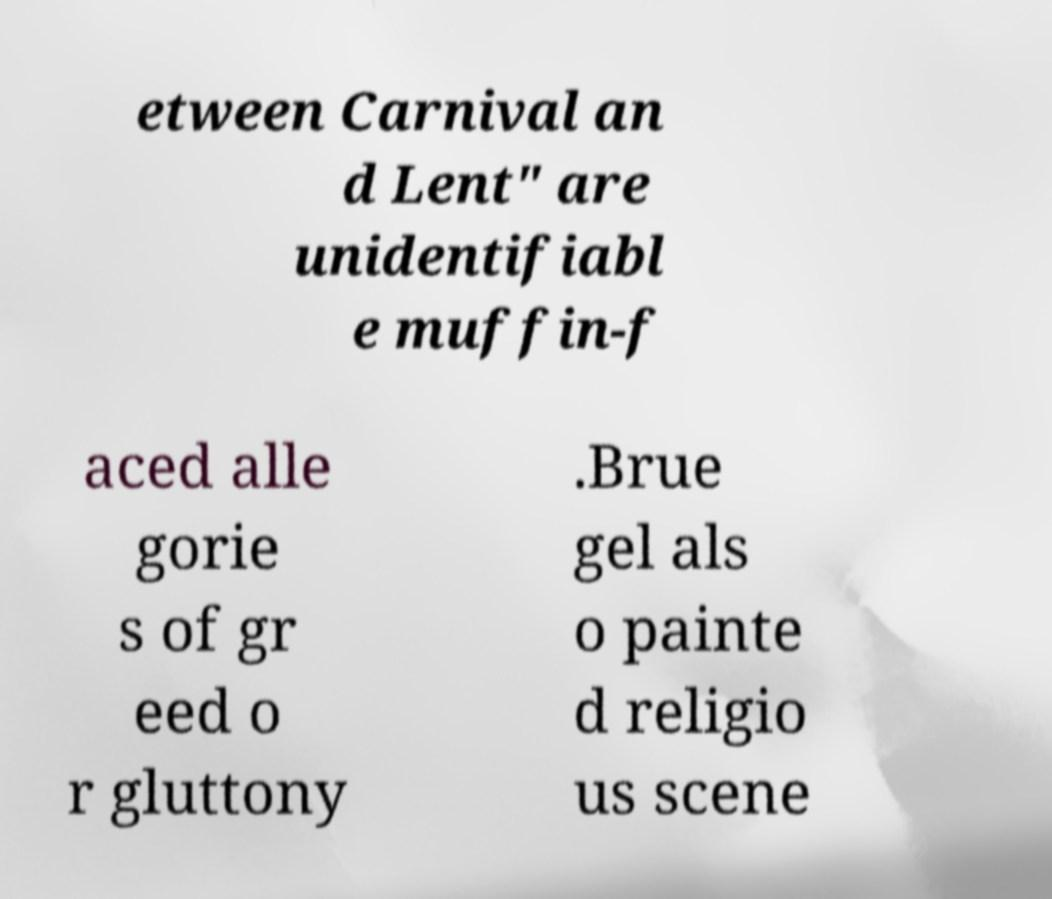Could you extract and type out the text from this image? etween Carnival an d Lent" are unidentifiabl e muffin-f aced alle gorie s of gr eed o r gluttony .Brue gel als o painte d religio us scene 